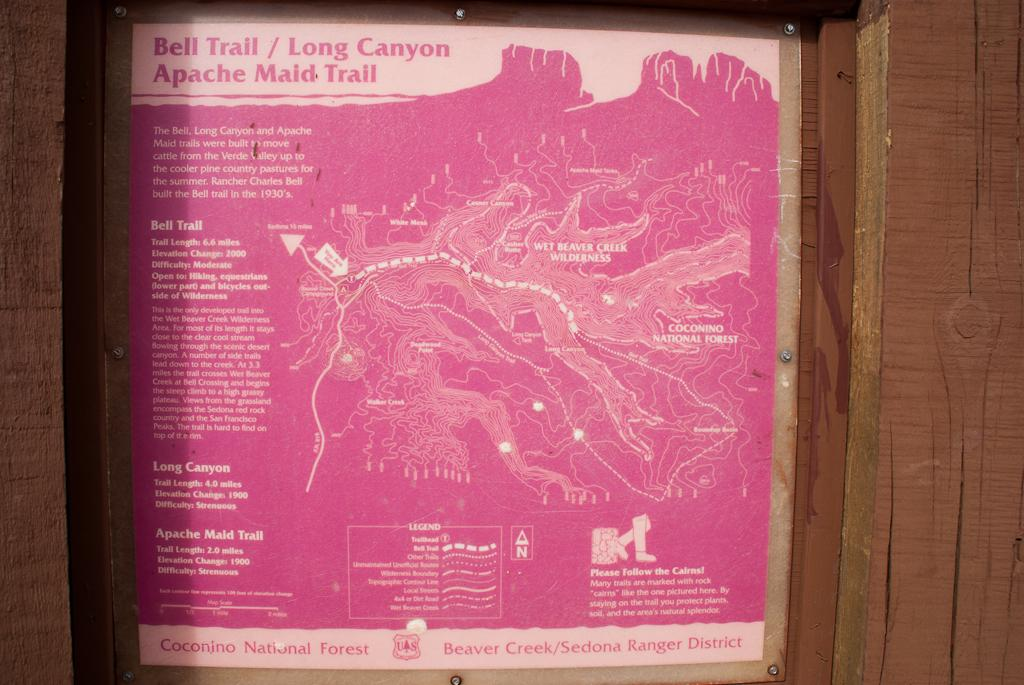<image>
Write a terse but informative summary of the picture. Bell Trail and Long Canyon Apache Maid trail map and information 